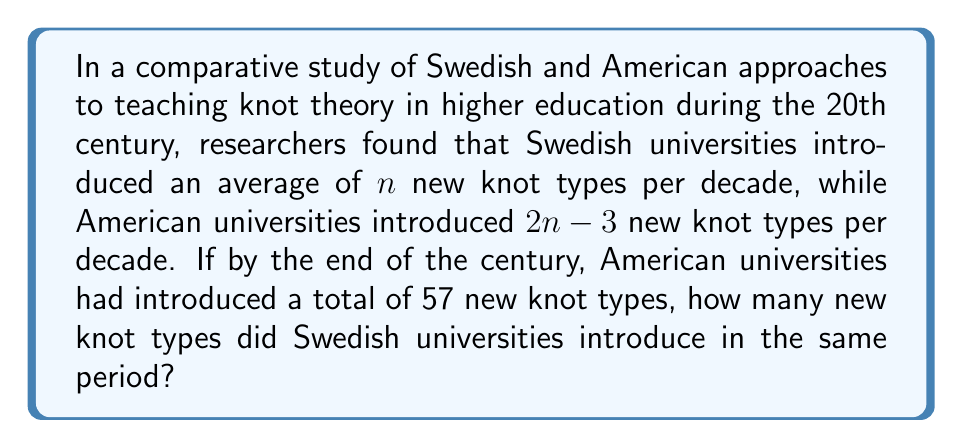Could you help me with this problem? 1. Let's define variables:
   $n$ = average number of new knot types introduced by Swedish universities per decade
   $2n-3$ = average number of new knot types introduced by American universities per decade

2. We know that American universities introduced 57 new knot types in total by the end of the century.
   The 20th century spans 10 decades, so we can set up the equation:
   $10(2n-3) = 57$

3. Solve the equation for $n$:
   $20n - 30 = 57$
   $20n = 87$
   $n = \frac{87}{20} = 4.35$

4. Now that we know $n$, we can calculate the number of new knot types introduced by Swedish universities:
   Swedish knot types per decade = $n = 4.35$
   Total decades = 10
   Total Swedish knot types = $10 \times 4.35 = 43.5$

5. Since we're dealing with whole knot types, we round to the nearest integer:
   $43.5 \approx 44$
Answer: 44 